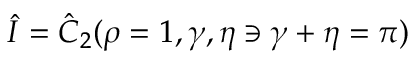Convert formula to latex. <formula><loc_0><loc_0><loc_500><loc_500>\hat { I } = \hat { C } _ { 2 } ( \rho = 1 , \gamma , \eta \ni \gamma + \eta = \pi )</formula> 